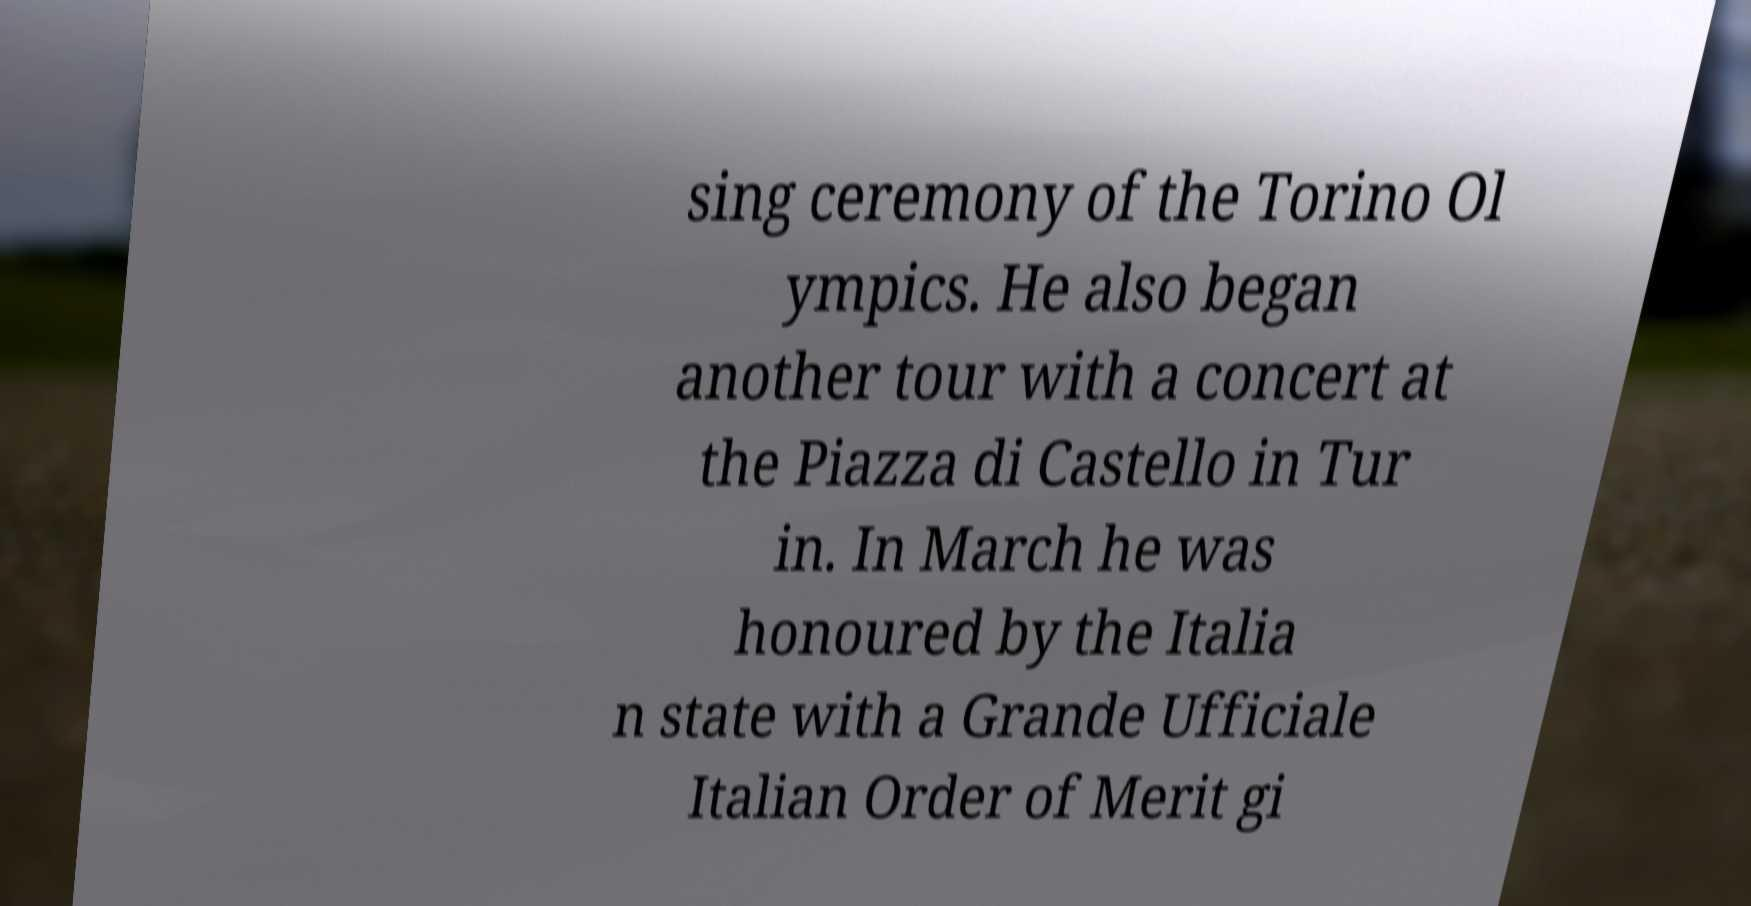Can you accurately transcribe the text from the provided image for me? sing ceremony of the Torino Ol ympics. He also began another tour with a concert at the Piazza di Castello in Tur in. In March he was honoured by the Italia n state with a Grande Ufficiale Italian Order of Merit gi 